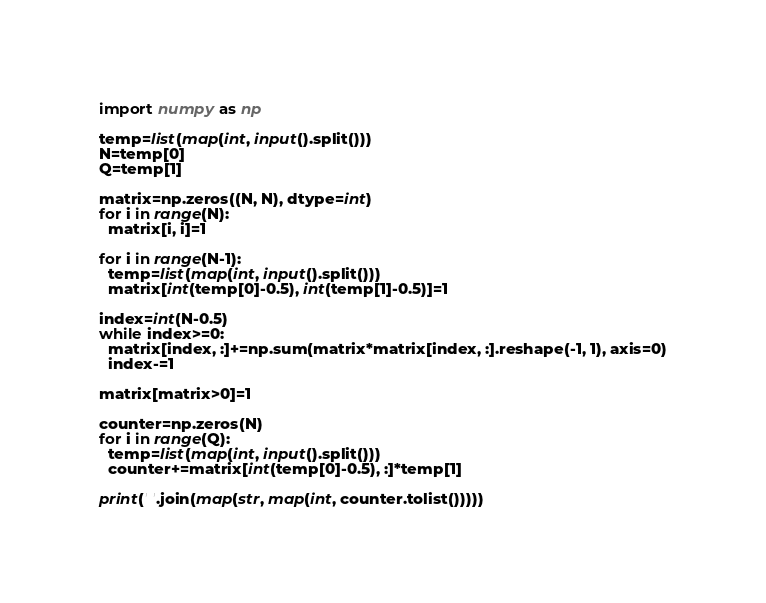Convert code to text. <code><loc_0><loc_0><loc_500><loc_500><_Python_>import numpy as np

temp=list(map(int, input().split()))
N=temp[0]
Q=temp[1]

matrix=np.zeros((N, N), dtype=int)
for i in range(N):
  matrix[i, i]=1

for i in range(N-1):
  temp=list(map(int, input().split()))
  matrix[int(temp[0]-0.5), int(temp[1]-0.5)]=1
  
index=int(N-0.5)
while index>=0:
  matrix[index, :]+=np.sum(matrix*matrix[index, :].reshape(-1, 1), axis=0)
  index-=1
  
matrix[matrix>0]=1

counter=np.zeros(N)
for i in range(Q):
  temp=list(map(int, input().split()))
  counter+=matrix[int(temp[0]-0.5), :]*temp[1]
  
print(' '.join(map(str, map(int, counter.tolist()))))</code> 